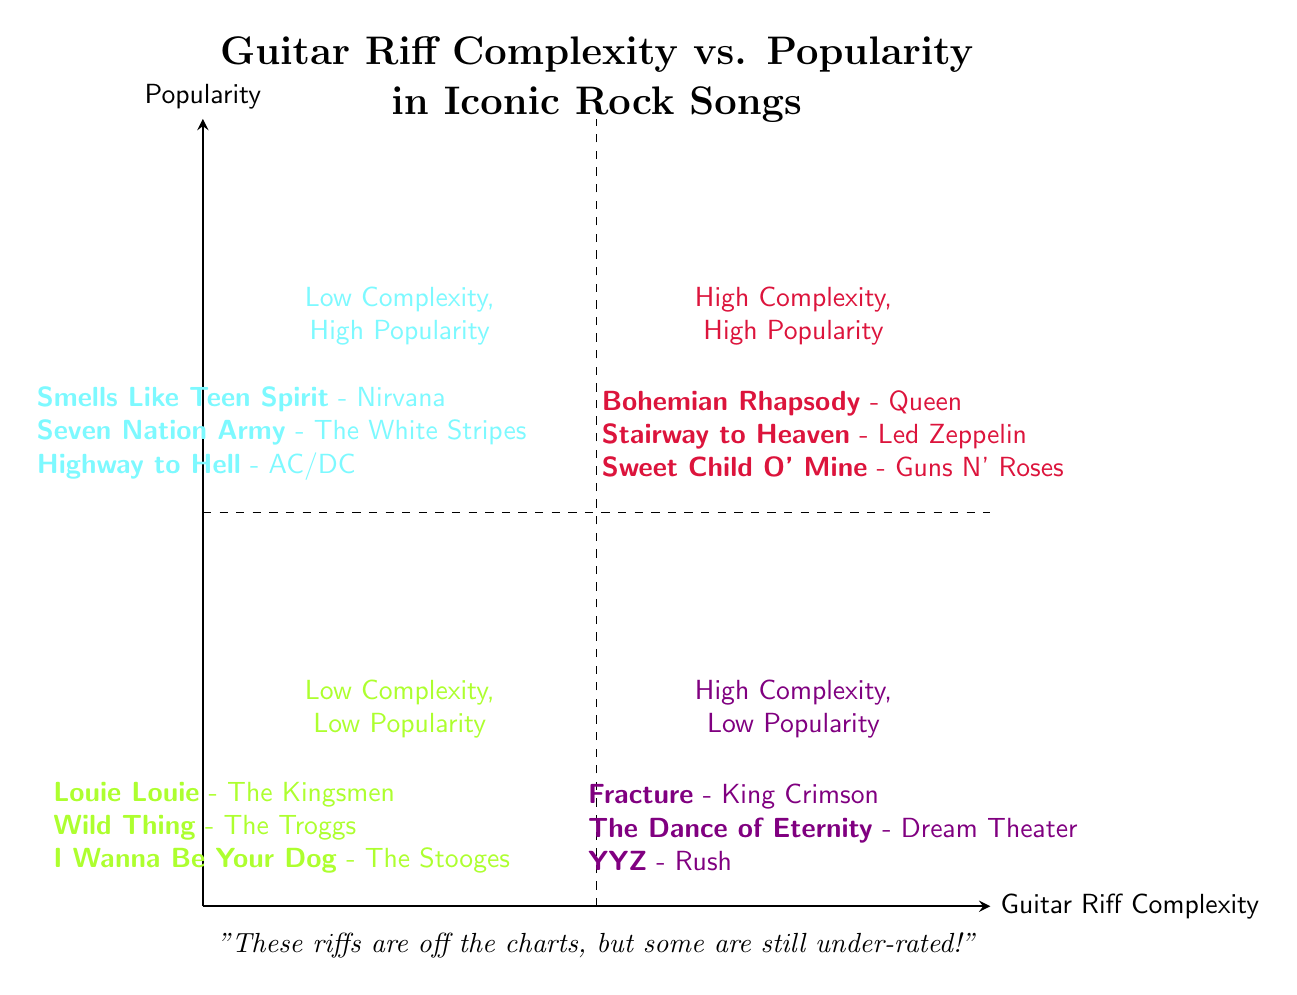What's in the high complexity, high popularity quadrant? In the diagram, the high complexity, high popularity quadrant contains three songs: "Bohemian Rhapsody" by Queen, "Stairway to Heaven" by Led Zeppelin, and "Sweet Child O' Mine" by Guns N' Roses.
Answer: "Bohemian Rhapsody", "Stairway to Heaven", "Sweet Child O' Mine" Which song is in the low complexity, high popularity quadrant? The low complexity, high popularity quadrant includes three songs, one of which is "Smells Like Teen Spirit" by Nirvana.
Answer: "Smells Like Teen Spirit" How many songs are listed in the low complexity, low popularity quadrant? There are three songs listed in the low complexity, low popularity quadrant: "Louie Louie," "Wild Thing," and "I Wanna Be Your Dog."
Answer: 3 In which quadrant would you find "YYZ"? "YYZ" is located in the high complexity, low popularity quadrant, which is indicated by the quadrant label and the example provided within it.
Answer: High Complexity, Low Popularity Which band has a song in both high complexity quadrants? The song "YYZ" by Rush is found in the high complexity, low popularity quadrant, while no songs from the high complexity, high popularity quadrant are by the same band. Thus, no band appears in both quadrants.
Answer: None How many quadrants are represented in the diagram? The diagram consists of four distinct quadrants, each representing different combinations of guitar riff complexity and popularity.
Answer: 4 What is the unique feature of the low complexity, low popularity quadrant compared to others? The unique feature of the low complexity, low popularity quadrant is that it contains songs that are less complex and less popular compared to other quadrants that have higher ratings in either complexity or popularity.
Answer: Less complex and less popular Which quadrant includes "The Dance of Eternity"? "The Dance of Eternity" is found in the high complexity, low popularity quadrant, where its unique complexity is emphasized compared to its popularity.
Answer: High Complexity, Low Popularity Name one song from the low complexity, high popularity quadrant. One song from the low complexity, high popularity quadrant is "Seven Nation Army" by The White Stripes.
Answer: "Seven Nation Army" 